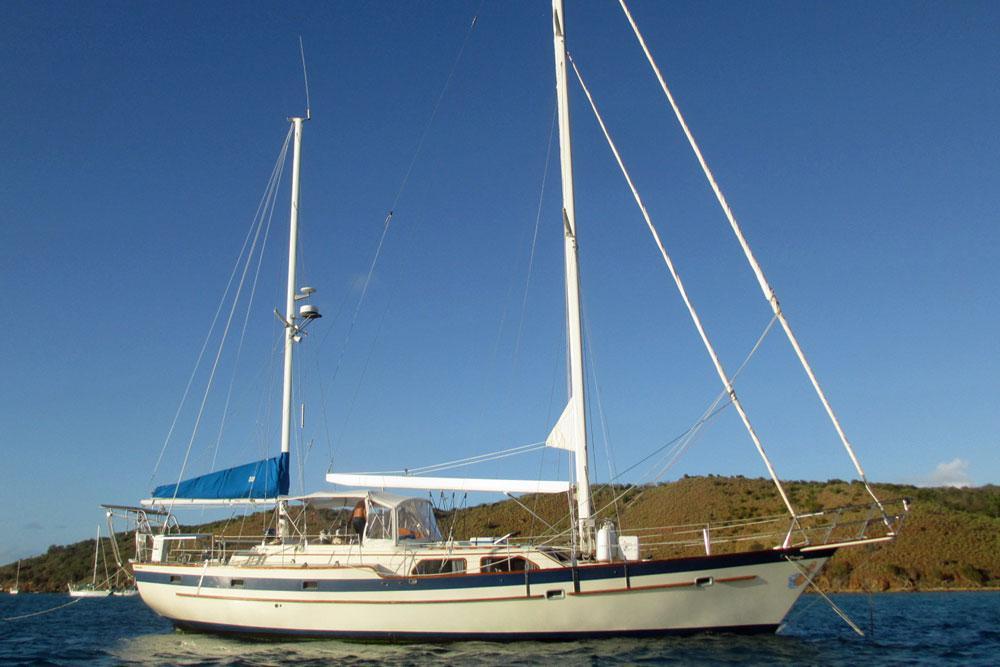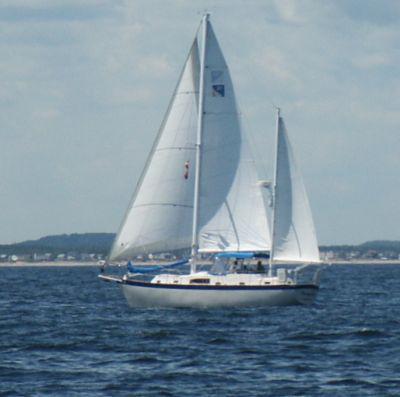The first image is the image on the left, the second image is the image on the right. Evaluate the accuracy of this statement regarding the images: "One of the boats has all its sails furled and is aimed toward the right.". Is it true? Answer yes or no. Yes. The first image is the image on the left, the second image is the image on the right. Analyze the images presented: Is the assertion "One of the images features a sailboat with its sails furled" valid? Answer yes or no. Yes. 